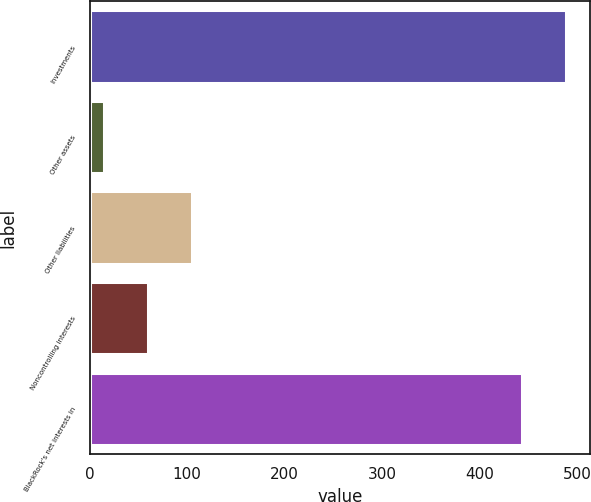Convert chart. <chart><loc_0><loc_0><loc_500><loc_500><bar_chart><fcel>Investments<fcel>Other assets<fcel>Other liabilities<fcel>Noncontrolling interests<fcel>BlackRock's net interests in<nl><fcel>489<fcel>15<fcel>105<fcel>60<fcel>444<nl></chart> 